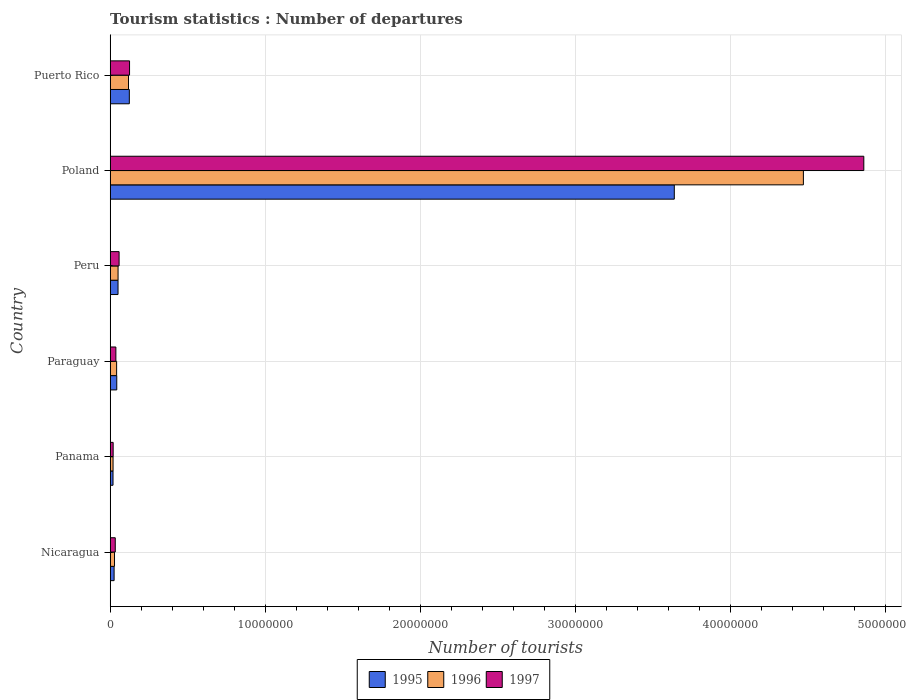How many different coloured bars are there?
Your answer should be very brief. 3. How many groups of bars are there?
Ensure brevity in your answer.  6. How many bars are there on the 3rd tick from the bottom?
Keep it short and to the point. 3. What is the label of the 4th group of bars from the top?
Your answer should be compact. Paraguay. In how many cases, is the number of bars for a given country not equal to the number of legend labels?
Provide a succinct answer. 0. What is the number of tourist departures in 1997 in Puerto Rico?
Give a very brief answer. 1.25e+06. Across all countries, what is the maximum number of tourist departures in 1995?
Give a very brief answer. 3.64e+07. Across all countries, what is the minimum number of tourist departures in 1996?
Offer a very short reply. 1.88e+05. In which country was the number of tourist departures in 1996 minimum?
Your answer should be compact. Panama. What is the total number of tourist departures in 1997 in the graph?
Make the answer very short. 5.13e+07. What is the difference between the number of tourist departures in 1995 in Poland and that in Puerto Rico?
Keep it short and to the point. 3.52e+07. What is the difference between the number of tourist departures in 1996 in Poland and the number of tourist departures in 1995 in Paraguay?
Your answer should be very brief. 4.43e+07. What is the average number of tourist departures in 1995 per country?
Your answer should be compact. 6.50e+06. What is the difference between the number of tourist departures in 1996 and number of tourist departures in 1997 in Paraguay?
Provide a short and direct response. 4.90e+04. What is the ratio of the number of tourist departures in 1997 in Nicaragua to that in Peru?
Your answer should be compact. 0.57. Is the number of tourist departures in 1997 in Paraguay less than that in Poland?
Your answer should be compact. Yes. Is the difference between the number of tourist departures in 1996 in Panama and Poland greater than the difference between the number of tourist departures in 1997 in Panama and Poland?
Offer a terse response. Yes. What is the difference between the highest and the second highest number of tourist departures in 1995?
Make the answer very short. 3.52e+07. What is the difference between the highest and the lowest number of tourist departures in 1997?
Your answer should be very brief. 4.84e+07. Is the sum of the number of tourist departures in 1996 in Paraguay and Puerto Rico greater than the maximum number of tourist departures in 1997 across all countries?
Ensure brevity in your answer.  No. Is it the case that in every country, the sum of the number of tourist departures in 1995 and number of tourist departures in 1997 is greater than the number of tourist departures in 1996?
Provide a succinct answer. Yes. How many bars are there?
Make the answer very short. 18. Are all the bars in the graph horizontal?
Provide a succinct answer. Yes. How many countries are there in the graph?
Your response must be concise. 6. Are the values on the major ticks of X-axis written in scientific E-notation?
Your answer should be compact. No. Does the graph contain grids?
Offer a very short reply. Yes. How many legend labels are there?
Make the answer very short. 3. What is the title of the graph?
Offer a very short reply. Tourism statistics : Number of departures. Does "1979" appear as one of the legend labels in the graph?
Provide a succinct answer. No. What is the label or title of the X-axis?
Make the answer very short. Number of tourists. What is the Number of tourists in 1995 in Nicaragua?
Offer a very short reply. 2.55e+05. What is the Number of tourists of 1996 in Nicaragua?
Offer a terse response. 2.82e+05. What is the Number of tourists in 1995 in Panama?
Provide a short and direct response. 1.85e+05. What is the Number of tourists of 1996 in Panama?
Offer a very short reply. 1.88e+05. What is the Number of tourists of 1997 in Panama?
Your answer should be very brief. 1.94e+05. What is the Number of tourists of 1995 in Paraguay?
Give a very brief answer. 4.27e+05. What is the Number of tourists in 1996 in Paraguay?
Your answer should be very brief. 4.18e+05. What is the Number of tourists in 1997 in Paraguay?
Offer a terse response. 3.69e+05. What is the Number of tourists in 1995 in Peru?
Your answer should be compact. 5.08e+05. What is the Number of tourists of 1996 in Peru?
Your response must be concise. 5.10e+05. What is the Number of tourists of 1997 in Peru?
Provide a succinct answer. 5.77e+05. What is the Number of tourists of 1995 in Poland?
Give a very brief answer. 3.64e+07. What is the Number of tourists of 1996 in Poland?
Your answer should be compact. 4.47e+07. What is the Number of tourists of 1997 in Poland?
Make the answer very short. 4.86e+07. What is the Number of tourists in 1995 in Puerto Rico?
Offer a terse response. 1.24e+06. What is the Number of tourists of 1996 in Puerto Rico?
Give a very brief answer. 1.18e+06. What is the Number of tourists in 1997 in Puerto Rico?
Your response must be concise. 1.25e+06. Across all countries, what is the maximum Number of tourists in 1995?
Provide a short and direct response. 3.64e+07. Across all countries, what is the maximum Number of tourists of 1996?
Keep it short and to the point. 4.47e+07. Across all countries, what is the maximum Number of tourists of 1997?
Your response must be concise. 4.86e+07. Across all countries, what is the minimum Number of tourists in 1995?
Provide a short and direct response. 1.85e+05. Across all countries, what is the minimum Number of tourists of 1996?
Ensure brevity in your answer.  1.88e+05. Across all countries, what is the minimum Number of tourists in 1997?
Your answer should be compact. 1.94e+05. What is the total Number of tourists of 1995 in the graph?
Keep it short and to the point. 3.90e+07. What is the total Number of tourists of 1996 in the graph?
Provide a short and direct response. 4.73e+07. What is the total Number of tourists of 1997 in the graph?
Provide a short and direct response. 5.13e+07. What is the difference between the Number of tourists of 1995 in Nicaragua and that in Panama?
Offer a very short reply. 7.00e+04. What is the difference between the Number of tourists in 1996 in Nicaragua and that in Panama?
Offer a very short reply. 9.40e+04. What is the difference between the Number of tourists in 1997 in Nicaragua and that in Panama?
Keep it short and to the point. 1.36e+05. What is the difference between the Number of tourists of 1995 in Nicaragua and that in Paraguay?
Provide a short and direct response. -1.72e+05. What is the difference between the Number of tourists of 1996 in Nicaragua and that in Paraguay?
Provide a short and direct response. -1.36e+05. What is the difference between the Number of tourists of 1997 in Nicaragua and that in Paraguay?
Make the answer very short. -3.90e+04. What is the difference between the Number of tourists of 1995 in Nicaragua and that in Peru?
Your answer should be very brief. -2.53e+05. What is the difference between the Number of tourists of 1996 in Nicaragua and that in Peru?
Offer a terse response. -2.28e+05. What is the difference between the Number of tourists in 1997 in Nicaragua and that in Peru?
Your answer should be compact. -2.47e+05. What is the difference between the Number of tourists in 1995 in Nicaragua and that in Poland?
Give a very brief answer. -3.61e+07. What is the difference between the Number of tourists of 1996 in Nicaragua and that in Poland?
Ensure brevity in your answer.  -4.44e+07. What is the difference between the Number of tourists of 1997 in Nicaragua and that in Poland?
Your response must be concise. -4.83e+07. What is the difference between the Number of tourists in 1995 in Nicaragua and that in Puerto Rico?
Give a very brief answer. -9.82e+05. What is the difference between the Number of tourists in 1996 in Nicaragua and that in Puerto Rico?
Provide a succinct answer. -9.02e+05. What is the difference between the Number of tourists of 1997 in Nicaragua and that in Puerto Rico?
Your answer should be very brief. -9.21e+05. What is the difference between the Number of tourists of 1995 in Panama and that in Paraguay?
Keep it short and to the point. -2.42e+05. What is the difference between the Number of tourists in 1996 in Panama and that in Paraguay?
Keep it short and to the point. -2.30e+05. What is the difference between the Number of tourists in 1997 in Panama and that in Paraguay?
Provide a short and direct response. -1.75e+05. What is the difference between the Number of tourists of 1995 in Panama and that in Peru?
Provide a succinct answer. -3.23e+05. What is the difference between the Number of tourists in 1996 in Panama and that in Peru?
Provide a succinct answer. -3.22e+05. What is the difference between the Number of tourists in 1997 in Panama and that in Peru?
Your answer should be compact. -3.83e+05. What is the difference between the Number of tourists of 1995 in Panama and that in Poland?
Provide a short and direct response. -3.62e+07. What is the difference between the Number of tourists in 1996 in Panama and that in Poland?
Give a very brief answer. -4.45e+07. What is the difference between the Number of tourists of 1997 in Panama and that in Poland?
Provide a short and direct response. -4.84e+07. What is the difference between the Number of tourists in 1995 in Panama and that in Puerto Rico?
Keep it short and to the point. -1.05e+06. What is the difference between the Number of tourists of 1996 in Panama and that in Puerto Rico?
Offer a very short reply. -9.96e+05. What is the difference between the Number of tourists of 1997 in Panama and that in Puerto Rico?
Provide a succinct answer. -1.06e+06. What is the difference between the Number of tourists in 1995 in Paraguay and that in Peru?
Give a very brief answer. -8.10e+04. What is the difference between the Number of tourists of 1996 in Paraguay and that in Peru?
Offer a very short reply. -9.20e+04. What is the difference between the Number of tourists in 1997 in Paraguay and that in Peru?
Make the answer very short. -2.08e+05. What is the difference between the Number of tourists of 1995 in Paraguay and that in Poland?
Give a very brief answer. -3.60e+07. What is the difference between the Number of tourists in 1996 in Paraguay and that in Poland?
Your response must be concise. -4.43e+07. What is the difference between the Number of tourists in 1997 in Paraguay and that in Poland?
Your response must be concise. -4.82e+07. What is the difference between the Number of tourists in 1995 in Paraguay and that in Puerto Rico?
Offer a very short reply. -8.10e+05. What is the difference between the Number of tourists of 1996 in Paraguay and that in Puerto Rico?
Make the answer very short. -7.66e+05. What is the difference between the Number of tourists in 1997 in Paraguay and that in Puerto Rico?
Make the answer very short. -8.82e+05. What is the difference between the Number of tourists of 1995 in Peru and that in Poland?
Offer a very short reply. -3.59e+07. What is the difference between the Number of tourists of 1996 in Peru and that in Poland?
Your answer should be compact. -4.42e+07. What is the difference between the Number of tourists in 1997 in Peru and that in Poland?
Your response must be concise. -4.80e+07. What is the difference between the Number of tourists in 1995 in Peru and that in Puerto Rico?
Provide a short and direct response. -7.29e+05. What is the difference between the Number of tourists of 1996 in Peru and that in Puerto Rico?
Your answer should be very brief. -6.74e+05. What is the difference between the Number of tourists of 1997 in Peru and that in Puerto Rico?
Ensure brevity in your answer.  -6.74e+05. What is the difference between the Number of tourists of 1995 in Poland and that in Puerto Rico?
Your answer should be very brief. 3.52e+07. What is the difference between the Number of tourists of 1996 in Poland and that in Puerto Rico?
Ensure brevity in your answer.  4.35e+07. What is the difference between the Number of tourists in 1997 in Poland and that in Puerto Rico?
Give a very brief answer. 4.74e+07. What is the difference between the Number of tourists of 1995 in Nicaragua and the Number of tourists of 1996 in Panama?
Offer a very short reply. 6.70e+04. What is the difference between the Number of tourists in 1995 in Nicaragua and the Number of tourists in 1997 in Panama?
Give a very brief answer. 6.10e+04. What is the difference between the Number of tourists in 1996 in Nicaragua and the Number of tourists in 1997 in Panama?
Keep it short and to the point. 8.80e+04. What is the difference between the Number of tourists in 1995 in Nicaragua and the Number of tourists in 1996 in Paraguay?
Keep it short and to the point. -1.63e+05. What is the difference between the Number of tourists of 1995 in Nicaragua and the Number of tourists of 1997 in Paraguay?
Your answer should be compact. -1.14e+05. What is the difference between the Number of tourists in 1996 in Nicaragua and the Number of tourists in 1997 in Paraguay?
Keep it short and to the point. -8.70e+04. What is the difference between the Number of tourists of 1995 in Nicaragua and the Number of tourists of 1996 in Peru?
Your response must be concise. -2.55e+05. What is the difference between the Number of tourists of 1995 in Nicaragua and the Number of tourists of 1997 in Peru?
Provide a short and direct response. -3.22e+05. What is the difference between the Number of tourists in 1996 in Nicaragua and the Number of tourists in 1997 in Peru?
Your response must be concise. -2.95e+05. What is the difference between the Number of tourists in 1995 in Nicaragua and the Number of tourists in 1996 in Poland?
Provide a succinct answer. -4.45e+07. What is the difference between the Number of tourists of 1995 in Nicaragua and the Number of tourists of 1997 in Poland?
Provide a succinct answer. -4.84e+07. What is the difference between the Number of tourists in 1996 in Nicaragua and the Number of tourists in 1997 in Poland?
Offer a very short reply. -4.83e+07. What is the difference between the Number of tourists of 1995 in Nicaragua and the Number of tourists of 1996 in Puerto Rico?
Your response must be concise. -9.29e+05. What is the difference between the Number of tourists in 1995 in Nicaragua and the Number of tourists in 1997 in Puerto Rico?
Your response must be concise. -9.96e+05. What is the difference between the Number of tourists of 1996 in Nicaragua and the Number of tourists of 1997 in Puerto Rico?
Offer a terse response. -9.69e+05. What is the difference between the Number of tourists of 1995 in Panama and the Number of tourists of 1996 in Paraguay?
Make the answer very short. -2.33e+05. What is the difference between the Number of tourists of 1995 in Panama and the Number of tourists of 1997 in Paraguay?
Your answer should be compact. -1.84e+05. What is the difference between the Number of tourists in 1996 in Panama and the Number of tourists in 1997 in Paraguay?
Offer a terse response. -1.81e+05. What is the difference between the Number of tourists of 1995 in Panama and the Number of tourists of 1996 in Peru?
Ensure brevity in your answer.  -3.25e+05. What is the difference between the Number of tourists in 1995 in Panama and the Number of tourists in 1997 in Peru?
Offer a terse response. -3.92e+05. What is the difference between the Number of tourists in 1996 in Panama and the Number of tourists in 1997 in Peru?
Provide a succinct answer. -3.89e+05. What is the difference between the Number of tourists of 1995 in Panama and the Number of tourists of 1996 in Poland?
Ensure brevity in your answer.  -4.45e+07. What is the difference between the Number of tourists of 1995 in Panama and the Number of tourists of 1997 in Poland?
Your answer should be compact. -4.84e+07. What is the difference between the Number of tourists of 1996 in Panama and the Number of tourists of 1997 in Poland?
Offer a very short reply. -4.84e+07. What is the difference between the Number of tourists of 1995 in Panama and the Number of tourists of 1996 in Puerto Rico?
Your answer should be very brief. -9.99e+05. What is the difference between the Number of tourists of 1995 in Panama and the Number of tourists of 1997 in Puerto Rico?
Offer a very short reply. -1.07e+06. What is the difference between the Number of tourists in 1996 in Panama and the Number of tourists in 1997 in Puerto Rico?
Provide a succinct answer. -1.06e+06. What is the difference between the Number of tourists of 1995 in Paraguay and the Number of tourists of 1996 in Peru?
Offer a terse response. -8.30e+04. What is the difference between the Number of tourists of 1996 in Paraguay and the Number of tourists of 1997 in Peru?
Keep it short and to the point. -1.59e+05. What is the difference between the Number of tourists in 1995 in Paraguay and the Number of tourists in 1996 in Poland?
Your answer should be compact. -4.43e+07. What is the difference between the Number of tourists of 1995 in Paraguay and the Number of tourists of 1997 in Poland?
Offer a very short reply. -4.82e+07. What is the difference between the Number of tourists in 1996 in Paraguay and the Number of tourists in 1997 in Poland?
Give a very brief answer. -4.82e+07. What is the difference between the Number of tourists in 1995 in Paraguay and the Number of tourists in 1996 in Puerto Rico?
Offer a terse response. -7.57e+05. What is the difference between the Number of tourists of 1995 in Paraguay and the Number of tourists of 1997 in Puerto Rico?
Your answer should be very brief. -8.24e+05. What is the difference between the Number of tourists of 1996 in Paraguay and the Number of tourists of 1997 in Puerto Rico?
Give a very brief answer. -8.33e+05. What is the difference between the Number of tourists of 1995 in Peru and the Number of tourists of 1996 in Poland?
Keep it short and to the point. -4.42e+07. What is the difference between the Number of tourists in 1995 in Peru and the Number of tourists in 1997 in Poland?
Offer a terse response. -4.81e+07. What is the difference between the Number of tourists of 1996 in Peru and the Number of tourists of 1997 in Poland?
Your answer should be very brief. -4.81e+07. What is the difference between the Number of tourists in 1995 in Peru and the Number of tourists in 1996 in Puerto Rico?
Give a very brief answer. -6.76e+05. What is the difference between the Number of tourists of 1995 in Peru and the Number of tourists of 1997 in Puerto Rico?
Offer a terse response. -7.43e+05. What is the difference between the Number of tourists of 1996 in Peru and the Number of tourists of 1997 in Puerto Rico?
Provide a short and direct response. -7.41e+05. What is the difference between the Number of tourists of 1995 in Poland and the Number of tourists of 1996 in Puerto Rico?
Provide a short and direct response. 3.52e+07. What is the difference between the Number of tourists of 1995 in Poland and the Number of tourists of 1997 in Puerto Rico?
Your answer should be compact. 3.51e+07. What is the difference between the Number of tourists of 1996 in Poland and the Number of tourists of 1997 in Puerto Rico?
Provide a short and direct response. 4.35e+07. What is the average Number of tourists in 1995 per country?
Keep it short and to the point. 6.50e+06. What is the average Number of tourists of 1996 per country?
Make the answer very short. 7.88e+06. What is the average Number of tourists of 1997 per country?
Offer a very short reply. 8.56e+06. What is the difference between the Number of tourists of 1995 and Number of tourists of 1996 in Nicaragua?
Offer a very short reply. -2.70e+04. What is the difference between the Number of tourists in 1995 and Number of tourists in 1997 in Nicaragua?
Give a very brief answer. -7.50e+04. What is the difference between the Number of tourists of 1996 and Number of tourists of 1997 in Nicaragua?
Provide a short and direct response. -4.80e+04. What is the difference between the Number of tourists of 1995 and Number of tourists of 1996 in Panama?
Provide a succinct answer. -3000. What is the difference between the Number of tourists in 1995 and Number of tourists in 1997 in Panama?
Provide a short and direct response. -9000. What is the difference between the Number of tourists in 1996 and Number of tourists in 1997 in Panama?
Offer a terse response. -6000. What is the difference between the Number of tourists in 1995 and Number of tourists in 1996 in Paraguay?
Offer a very short reply. 9000. What is the difference between the Number of tourists of 1995 and Number of tourists of 1997 in Paraguay?
Your answer should be compact. 5.80e+04. What is the difference between the Number of tourists in 1996 and Number of tourists in 1997 in Paraguay?
Give a very brief answer. 4.90e+04. What is the difference between the Number of tourists of 1995 and Number of tourists of 1996 in Peru?
Your answer should be compact. -2000. What is the difference between the Number of tourists in 1995 and Number of tourists in 1997 in Peru?
Ensure brevity in your answer.  -6.90e+04. What is the difference between the Number of tourists in 1996 and Number of tourists in 1997 in Peru?
Ensure brevity in your answer.  -6.70e+04. What is the difference between the Number of tourists of 1995 and Number of tourists of 1996 in Poland?
Offer a terse response. -8.33e+06. What is the difference between the Number of tourists of 1995 and Number of tourists of 1997 in Poland?
Offer a terse response. -1.22e+07. What is the difference between the Number of tourists in 1996 and Number of tourists in 1997 in Poland?
Keep it short and to the point. -3.90e+06. What is the difference between the Number of tourists of 1995 and Number of tourists of 1996 in Puerto Rico?
Provide a succinct answer. 5.30e+04. What is the difference between the Number of tourists in 1995 and Number of tourists in 1997 in Puerto Rico?
Provide a succinct answer. -1.40e+04. What is the difference between the Number of tourists in 1996 and Number of tourists in 1997 in Puerto Rico?
Ensure brevity in your answer.  -6.70e+04. What is the ratio of the Number of tourists in 1995 in Nicaragua to that in Panama?
Provide a short and direct response. 1.38. What is the ratio of the Number of tourists in 1996 in Nicaragua to that in Panama?
Provide a short and direct response. 1.5. What is the ratio of the Number of tourists in 1997 in Nicaragua to that in Panama?
Your answer should be very brief. 1.7. What is the ratio of the Number of tourists of 1995 in Nicaragua to that in Paraguay?
Offer a terse response. 0.6. What is the ratio of the Number of tourists in 1996 in Nicaragua to that in Paraguay?
Your answer should be compact. 0.67. What is the ratio of the Number of tourists in 1997 in Nicaragua to that in Paraguay?
Offer a very short reply. 0.89. What is the ratio of the Number of tourists of 1995 in Nicaragua to that in Peru?
Your answer should be compact. 0.5. What is the ratio of the Number of tourists in 1996 in Nicaragua to that in Peru?
Your answer should be very brief. 0.55. What is the ratio of the Number of tourists in 1997 in Nicaragua to that in Peru?
Make the answer very short. 0.57. What is the ratio of the Number of tourists of 1995 in Nicaragua to that in Poland?
Provide a succinct answer. 0.01. What is the ratio of the Number of tourists of 1996 in Nicaragua to that in Poland?
Your answer should be compact. 0.01. What is the ratio of the Number of tourists in 1997 in Nicaragua to that in Poland?
Provide a succinct answer. 0.01. What is the ratio of the Number of tourists in 1995 in Nicaragua to that in Puerto Rico?
Make the answer very short. 0.21. What is the ratio of the Number of tourists of 1996 in Nicaragua to that in Puerto Rico?
Give a very brief answer. 0.24. What is the ratio of the Number of tourists of 1997 in Nicaragua to that in Puerto Rico?
Provide a succinct answer. 0.26. What is the ratio of the Number of tourists of 1995 in Panama to that in Paraguay?
Give a very brief answer. 0.43. What is the ratio of the Number of tourists in 1996 in Panama to that in Paraguay?
Your response must be concise. 0.45. What is the ratio of the Number of tourists in 1997 in Panama to that in Paraguay?
Provide a succinct answer. 0.53. What is the ratio of the Number of tourists in 1995 in Panama to that in Peru?
Your answer should be very brief. 0.36. What is the ratio of the Number of tourists in 1996 in Panama to that in Peru?
Make the answer very short. 0.37. What is the ratio of the Number of tourists in 1997 in Panama to that in Peru?
Give a very brief answer. 0.34. What is the ratio of the Number of tourists of 1995 in Panama to that in Poland?
Keep it short and to the point. 0.01. What is the ratio of the Number of tourists of 1996 in Panama to that in Poland?
Your answer should be very brief. 0. What is the ratio of the Number of tourists in 1997 in Panama to that in Poland?
Keep it short and to the point. 0. What is the ratio of the Number of tourists in 1995 in Panama to that in Puerto Rico?
Ensure brevity in your answer.  0.15. What is the ratio of the Number of tourists of 1996 in Panama to that in Puerto Rico?
Provide a short and direct response. 0.16. What is the ratio of the Number of tourists of 1997 in Panama to that in Puerto Rico?
Offer a terse response. 0.16. What is the ratio of the Number of tourists of 1995 in Paraguay to that in Peru?
Ensure brevity in your answer.  0.84. What is the ratio of the Number of tourists in 1996 in Paraguay to that in Peru?
Offer a very short reply. 0.82. What is the ratio of the Number of tourists in 1997 in Paraguay to that in Peru?
Your answer should be very brief. 0.64. What is the ratio of the Number of tourists of 1995 in Paraguay to that in Poland?
Your response must be concise. 0.01. What is the ratio of the Number of tourists of 1996 in Paraguay to that in Poland?
Offer a terse response. 0.01. What is the ratio of the Number of tourists of 1997 in Paraguay to that in Poland?
Keep it short and to the point. 0.01. What is the ratio of the Number of tourists in 1995 in Paraguay to that in Puerto Rico?
Keep it short and to the point. 0.35. What is the ratio of the Number of tourists of 1996 in Paraguay to that in Puerto Rico?
Your answer should be compact. 0.35. What is the ratio of the Number of tourists of 1997 in Paraguay to that in Puerto Rico?
Give a very brief answer. 0.29. What is the ratio of the Number of tourists of 1995 in Peru to that in Poland?
Keep it short and to the point. 0.01. What is the ratio of the Number of tourists in 1996 in Peru to that in Poland?
Offer a terse response. 0.01. What is the ratio of the Number of tourists in 1997 in Peru to that in Poland?
Ensure brevity in your answer.  0.01. What is the ratio of the Number of tourists in 1995 in Peru to that in Puerto Rico?
Your answer should be compact. 0.41. What is the ratio of the Number of tourists in 1996 in Peru to that in Puerto Rico?
Ensure brevity in your answer.  0.43. What is the ratio of the Number of tourists in 1997 in Peru to that in Puerto Rico?
Your answer should be compact. 0.46. What is the ratio of the Number of tourists of 1995 in Poland to that in Puerto Rico?
Ensure brevity in your answer.  29.42. What is the ratio of the Number of tourists in 1996 in Poland to that in Puerto Rico?
Offer a terse response. 37.76. What is the ratio of the Number of tourists of 1997 in Poland to that in Puerto Rico?
Your response must be concise. 38.86. What is the difference between the highest and the second highest Number of tourists in 1995?
Provide a short and direct response. 3.52e+07. What is the difference between the highest and the second highest Number of tourists of 1996?
Make the answer very short. 4.35e+07. What is the difference between the highest and the second highest Number of tourists of 1997?
Provide a short and direct response. 4.74e+07. What is the difference between the highest and the lowest Number of tourists of 1995?
Your response must be concise. 3.62e+07. What is the difference between the highest and the lowest Number of tourists in 1996?
Keep it short and to the point. 4.45e+07. What is the difference between the highest and the lowest Number of tourists of 1997?
Offer a very short reply. 4.84e+07. 